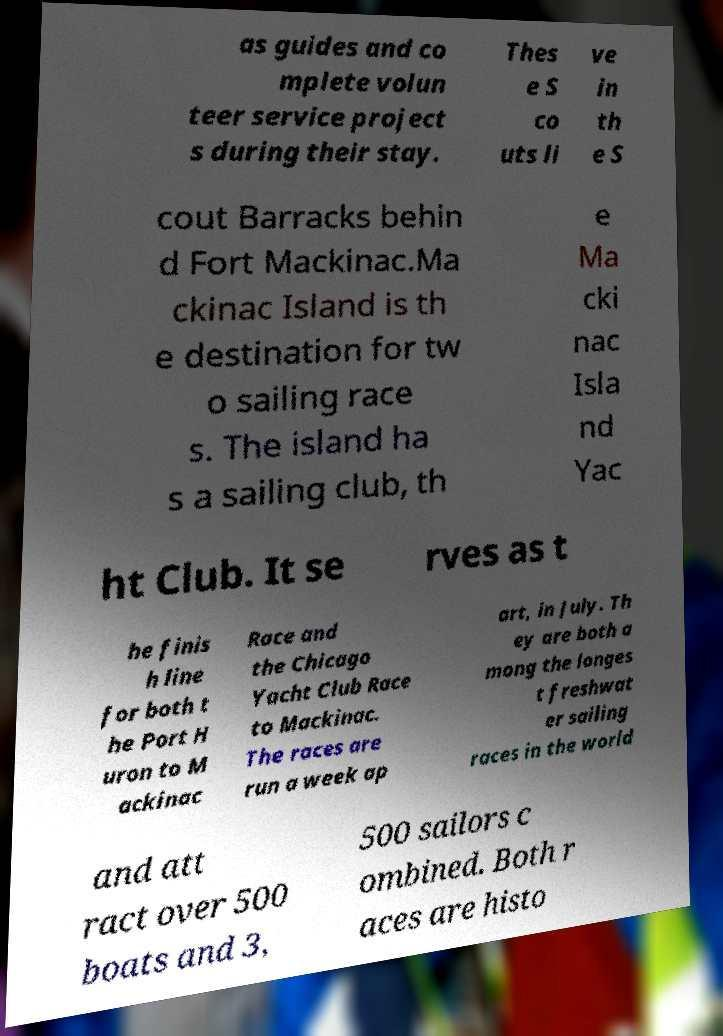Can you accurately transcribe the text from the provided image for me? as guides and co mplete volun teer service project s during their stay. Thes e S co uts li ve in th e S cout Barracks behin d Fort Mackinac.Ma ckinac Island is th e destination for tw o sailing race s. The island ha s a sailing club, th e Ma cki nac Isla nd Yac ht Club. It se rves as t he finis h line for both t he Port H uron to M ackinac Race and the Chicago Yacht Club Race to Mackinac. The races are run a week ap art, in July. Th ey are both a mong the longes t freshwat er sailing races in the world and att ract over 500 boats and 3, 500 sailors c ombined. Both r aces are histo 